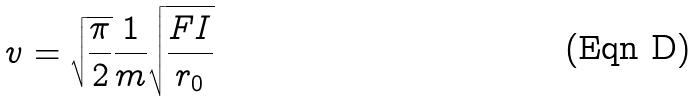Convert formula to latex. <formula><loc_0><loc_0><loc_500><loc_500>v = \sqrt { \frac { \pi } { 2 } } \frac { 1 } { m } \sqrt { \frac { F I } { r _ { 0 } } }</formula> 